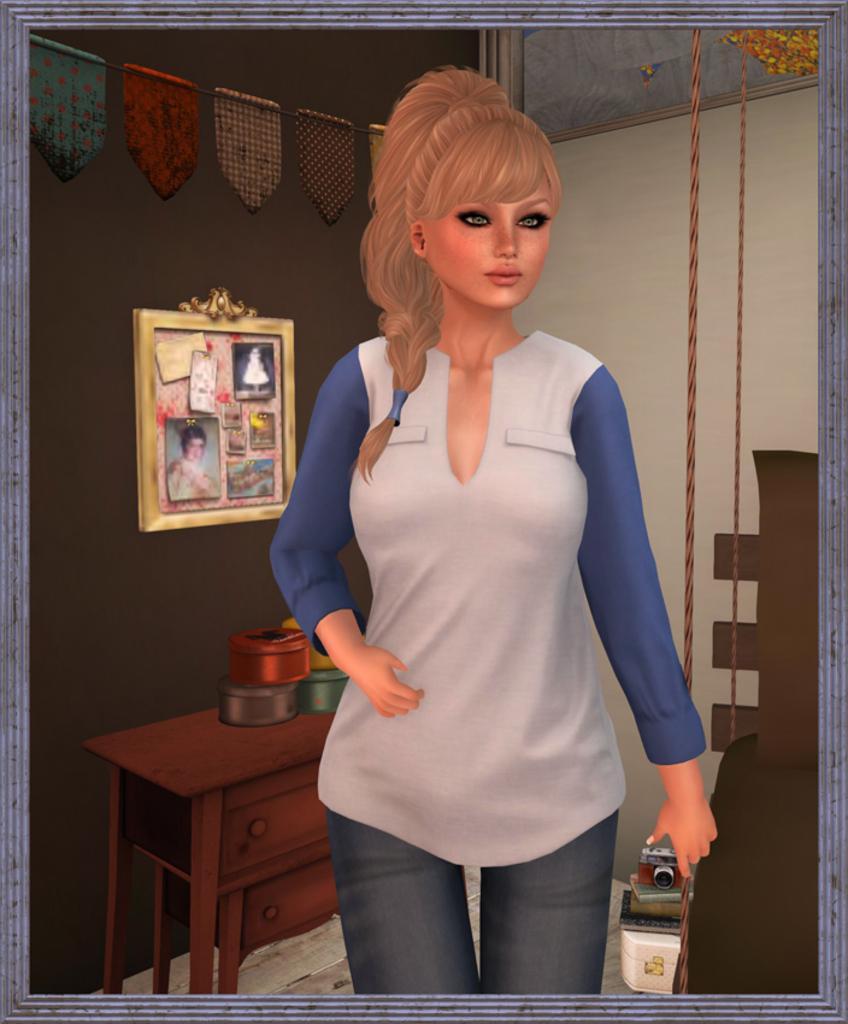In one or two sentences, can you explain what this image depicts? This is a graphic image in the middle we can see one lady she is holding camera. Coming to the background we can see wall and photo frame and table. 